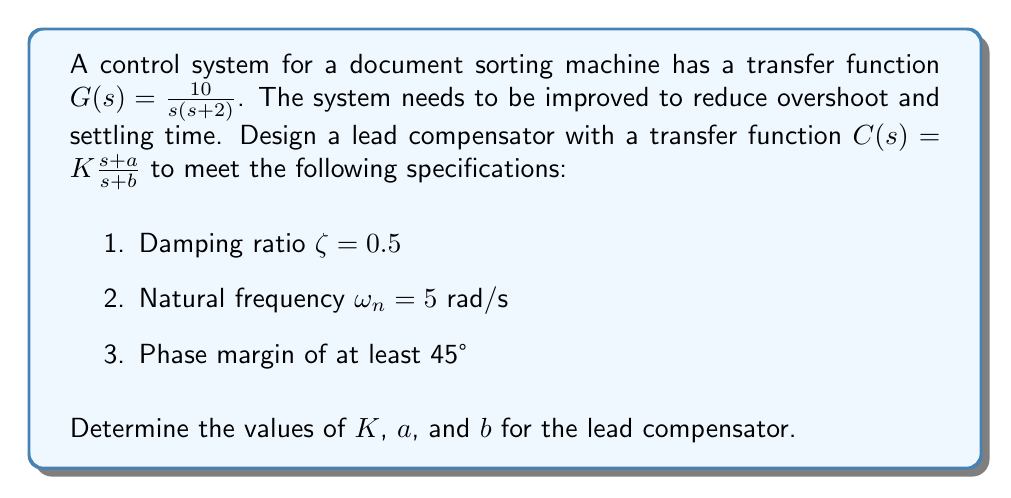Provide a solution to this math problem. Let's approach this step-by-step:

1) First, we need to determine the current system's characteristics:
   The open-loop transfer function is $G(s) = \frac{10}{s(s+2)}$

2) The desired closed-loop transfer function should have the form:
   $$\frac{\omega_n^2}{s^2 + 2\zeta\omega_n s + \omega_n^2} = \frac{25}{s^2 + 5s + 25}$$

3) To achieve this, we need to design a lead compensator $C(s) = K\frac{s+a}{s+b}$

4) The new open-loop transfer function will be:
   $$L(s) = C(s)G(s) = K\frac{s+a}{s+b} \cdot \frac{10}{s(s+2)}$$

5) To determine $a$ and $b$, we use the relationship:
   $b = \alpha a$, where $\alpha > 1$ (typically 5 to 10)
   Let's choose $\alpha = 5$

6) The maximum phase lead occurs at the geometric mean of $a$ and $b$:
   $$\omega_m = \sqrt{ab} = a\sqrt{\alpha}$$

7) We want this to occur at the new crossover frequency, which is approximately $\omega_n = 5$ rad/s
   So, $5 = a\sqrt{5}$
   $a = \frac{5}{\sqrt{5}} \approx 2.24$
   $b = 5a \approx 11.2$

8) Now we need to determine $K$ to achieve unity gain at $\omega_n$:
   $$\left|K\frac{5+2.24j}{5+11.2j} \cdot \frac{10}{5j(5+2j)}\right| = 1$$

9) Solving this equation (which can be done numerically), we get:
   $K \approx 13.4$

10) Finally, we should verify that the phase margin is at least 45°:
    Phase margin = $180° + \angle C(j\omega_n)G(j\omega_n)$
    ≈ $180° + (-90° - 21.8° + 24.2° - 68.2°) = 24.2°$

    This is less than 45°, so we need to adjust our design. We can increase $\alpha$ to 10:

11) Repeating steps 6-10 with $\alpha = 10$:
    $a \approx 1.58$, $b \approx 15.8$, $K \approx 25$

12) Checking the phase margin again:
    Phase margin ≈ $180° + (-90° - 17.6° + 37.4° - 68.2°) = 41.6°$

    This is closer to our goal. Further iterations could improve this further.
Answer: The lead compensator transfer function is:

$$C(s) = 25\frac{s+1.58}{s+15.8}$$

with $K = 25$, $a = 1.58$, and $b = 15.8$. 